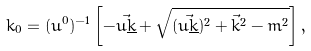<formula> <loc_0><loc_0><loc_500><loc_500>k _ { 0 } = ( u ^ { 0 } ) ^ { - 1 } \left [ - \vec { u \underline { k } } + \sqrt { ( \vec { u \underline { k } } ) ^ { 2 } + \vec { k } ^ { 2 } - m ^ { 2 } } \right ] ,</formula> 